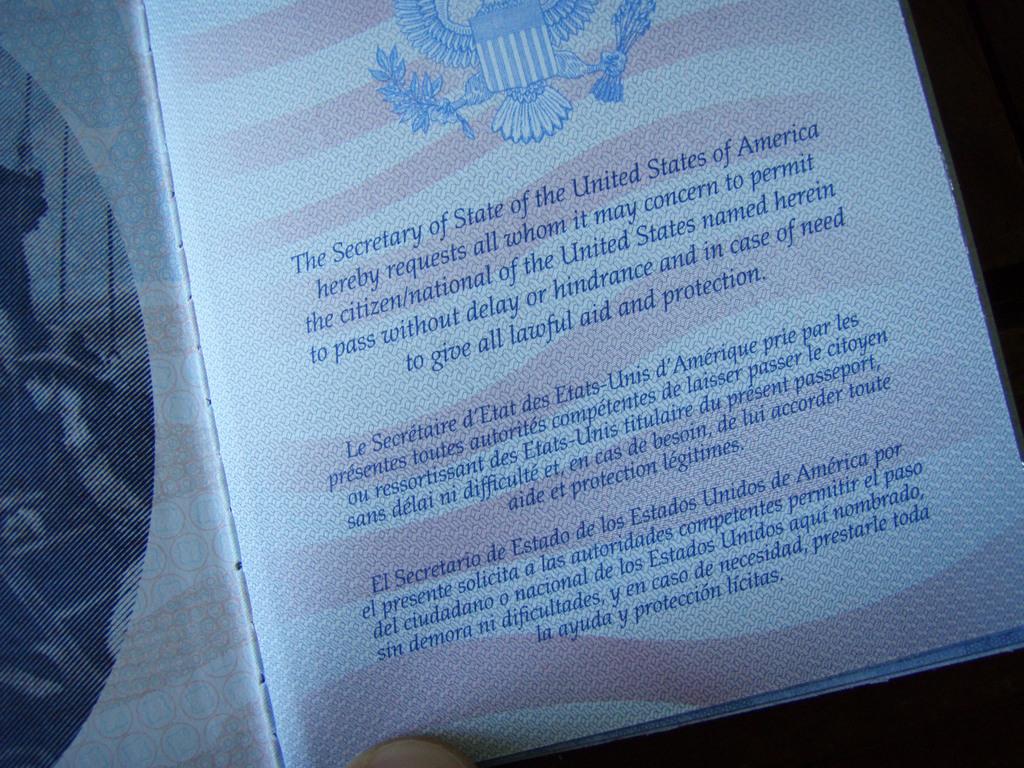Is the citizen allowed to pass without delay?
Make the answer very short. Yes. Who is requesting protection for said american citizen?
Make the answer very short. The secretary of state. 